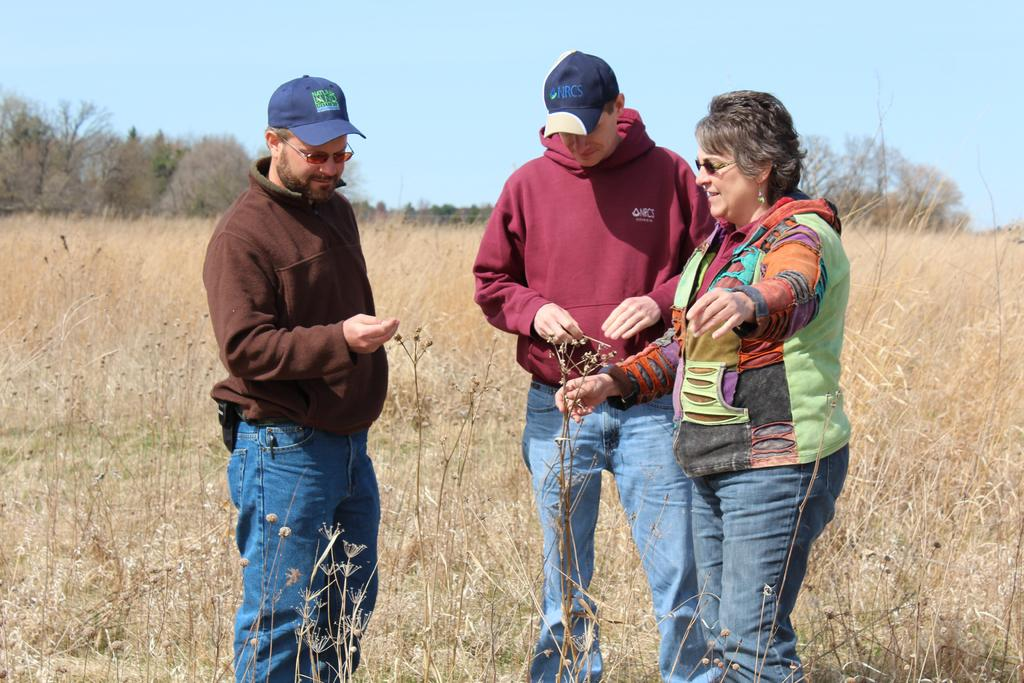How many people are in the image? There are two men and a woman in the image. What are the men wearing on their heads? The men are wearing caps. What accessory do the people in the image have in common? The people in the image are wearing glasses. What can be seen in the background of the image? There is grass, trees, and the sky visible in the background of the image. What type of bears can be seen interacting with the people in the image? There are no bears present in the image; it features two men and a woman. What thought is the woman having in the image? The image does not depict the thoughts of the woman or any of the people; it only shows their physical appearance and actions. 